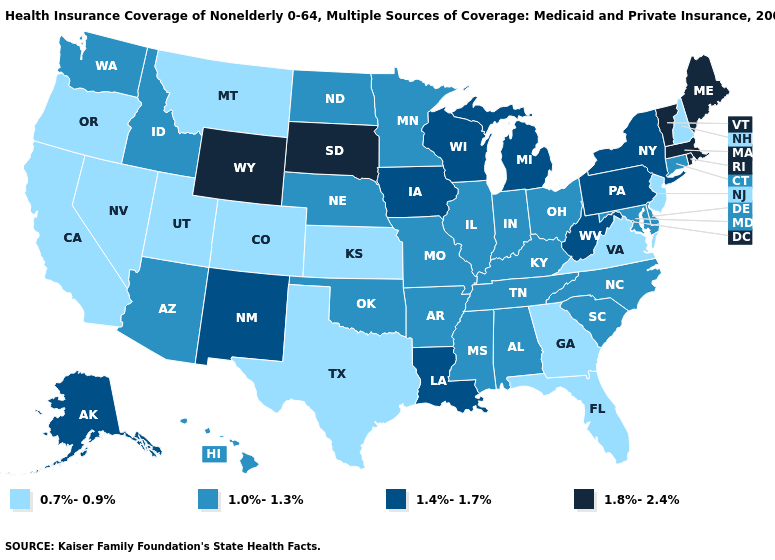Does Arkansas have the highest value in the USA?
Short answer required. No. Does the map have missing data?
Concise answer only. No. What is the highest value in the USA?
Short answer required. 1.8%-2.4%. Among the states that border Colorado , does Wyoming have the highest value?
Give a very brief answer. Yes. Does the map have missing data?
Be succinct. No. Does Washington have the highest value in the USA?
Give a very brief answer. No. Does Iowa have the lowest value in the USA?
Quick response, please. No. What is the value of Ohio?
Write a very short answer. 1.0%-1.3%. Which states have the lowest value in the MidWest?
Give a very brief answer. Kansas. What is the highest value in states that border New Jersey?
Write a very short answer. 1.4%-1.7%. Which states have the lowest value in the Northeast?
Quick response, please. New Hampshire, New Jersey. What is the value of Oregon?
Keep it brief. 0.7%-0.9%. What is the highest value in the Northeast ?
Concise answer only. 1.8%-2.4%. Does the first symbol in the legend represent the smallest category?
Be succinct. Yes. Does Colorado have the lowest value in the USA?
Write a very short answer. Yes. 